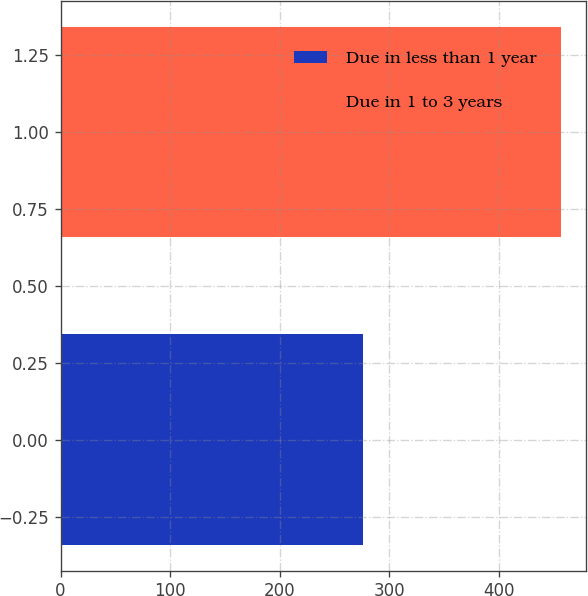Convert chart. <chart><loc_0><loc_0><loc_500><loc_500><bar_chart><fcel>Due in less than 1 year<fcel>Due in 1 to 3 years<nl><fcel>276<fcel>457<nl></chart> 